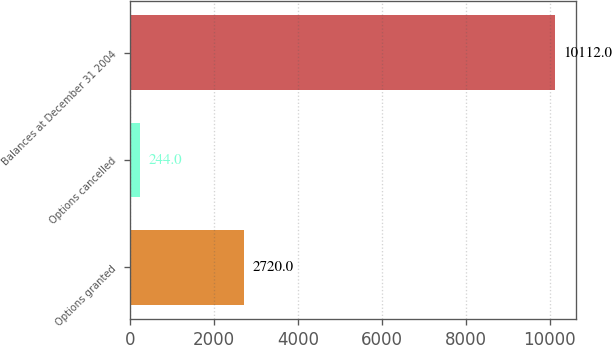Convert chart. <chart><loc_0><loc_0><loc_500><loc_500><bar_chart><fcel>Options granted<fcel>Options cancelled<fcel>Balances at December 31 2004<nl><fcel>2720<fcel>244<fcel>10112<nl></chart> 